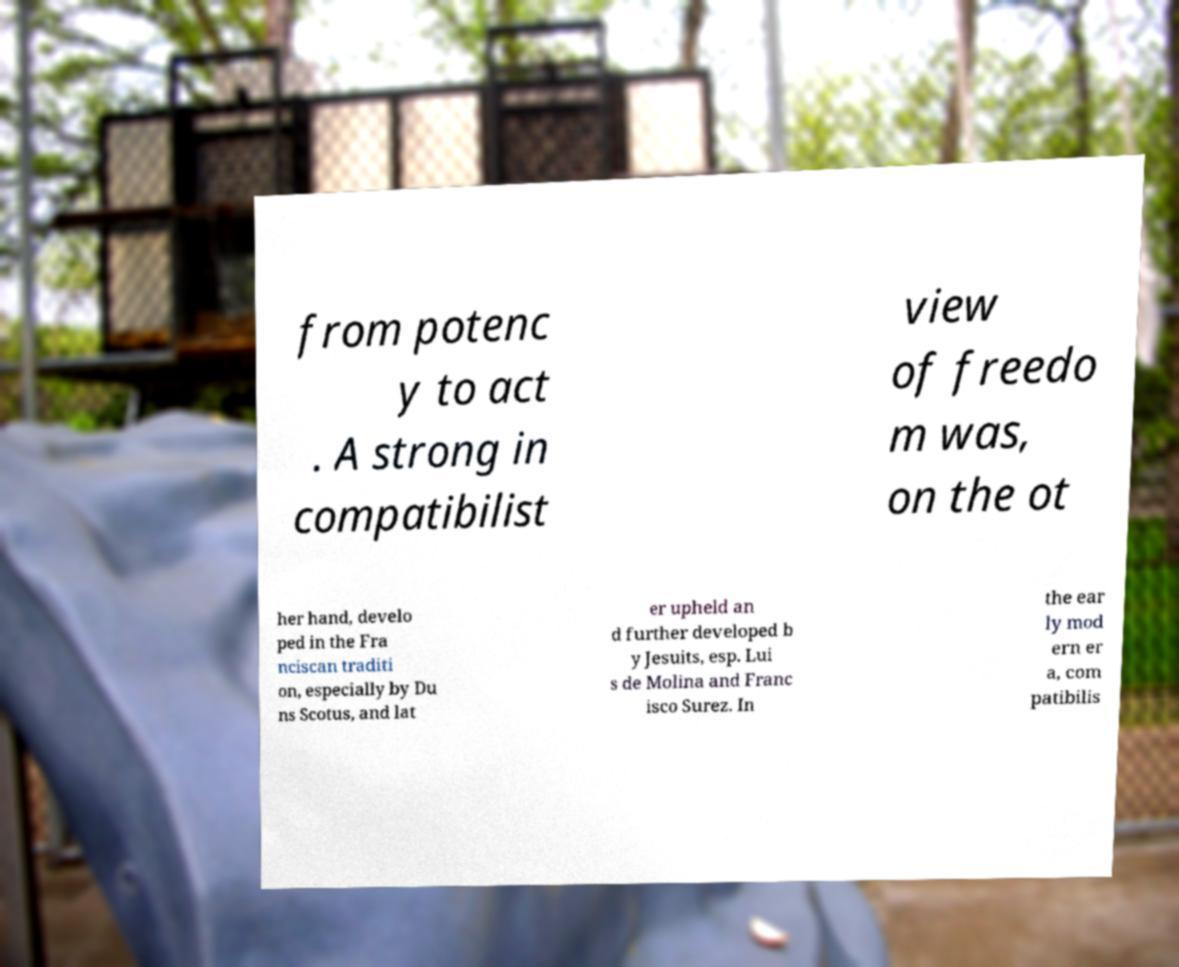Could you extract and type out the text from this image? from potenc y to act . A strong in compatibilist view of freedo m was, on the ot her hand, develo ped in the Fra nciscan traditi on, especially by Du ns Scotus, and lat er upheld an d further developed b y Jesuits, esp. Lui s de Molina and Franc isco Surez. In the ear ly mod ern er a, com patibilis 